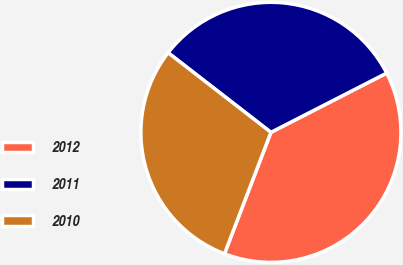Convert chart to OTSL. <chart><loc_0><loc_0><loc_500><loc_500><pie_chart><fcel>2012<fcel>2011<fcel>2010<nl><fcel>38.35%<fcel>31.98%<fcel>29.67%<nl></chart> 